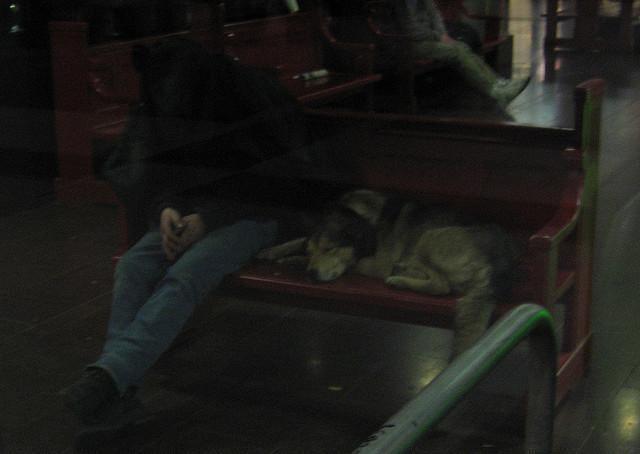How many people are in this image?
Give a very brief answer. 2. How many benches are there?
Give a very brief answer. 4. 